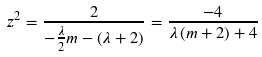Convert formula to latex. <formula><loc_0><loc_0><loc_500><loc_500>z ^ { 2 } = \frac { 2 } { - \frac { \lambda } { 2 } m - \left ( \lambda + 2 \right ) } = \frac { - 4 } { \lambda \left ( m + 2 \right ) + 4 }</formula> 